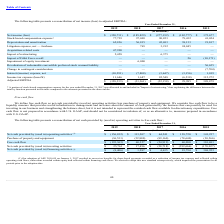According to Fitbit's financial document, How does the company define free cash flows? Net cash provided by (used in) operating activities less purchase of property and equipment. The document states: "We define free cash flow as net cash provided by (used in) operating activities less purchase of property and equipment. We consider free cash flow to..." Also, When did the company adopt ASU 2016-09? According to the financial document, January 1, 2017. The relevant text states: "(1) Our adoption of ASU 2016-09 on January 1, 2017 resulted in excess tax benefits for share-based payments recorded as a reduction of income tax expe..." Also, What is the net cash provided by operating activities in 2015? According to the financial document, $141,257 (in thousands). The relevant text states: "es (1) $ (156,832) $ 113,207 $ 64,241 $ 138,720 $ 141,257..." Also, can you calculate: What is the difference in the net cash provided by investing activities between 2018 and 2019? Based on the calculation: 25,761-17,496, the result is 8265 (in thousands). This is based on the information: "cash provided by (used in) investing activities $ 25,761 $ 17,496 $ (28,718) $ (392,666) $ (170,027) ided by (used in) investing activities $ 25,761 $ 17,496 $ (28,718) $ (392,666) $ (170,027)..." The key data points involved are: 17,496, 25,761. Also, can you calculate: What is the average net cash provided by operating activities for 2016 and 2017? To answer this question, I need to perform calculations using the financial data. The calculation is: (64,241+138,720)/2, which equals 101480.5 (in thousands). This is based on the information: "g activities (1) $ (156,832) $ 113,207 $ 64,241 $ 138,720 $ 141,257 operating activities (1) $ (156,832) $ 113,207 $ 64,241 $ 138,720 $ 141,257..." The key data points involved are: 138,720, 64,241. Also, can you calculate: What is the percentage change for net cash provided by financing activities from 2017 to 2018? To answer this question, I need to perform calculations using the financial data. The calculation is: (4,635-1,287)/4,635, which equals 72.23 (percentage). This is based on the information: "in) financing activities (1) $ (8,406) $ 1,287 $ 4,635 $ 19,794 $ 368,953 by (used in) financing activities (1) $ (8,406) $ 1,287 $ 4,635 $ 19,794 $ 368,953..." The key data points involved are: 1,287, 4,635. 